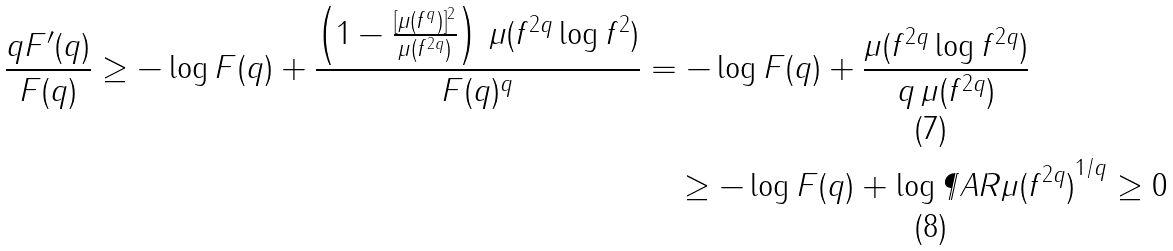<formula> <loc_0><loc_0><loc_500><loc_500>\frac { q F ^ { \prime } ( q ) } { F ( q ) } \geq - \log F ( q ) + \frac { \left ( 1 - \frac { [ \mu ( f ^ { q } ) ] ^ { 2 } } { \mu ( f ^ { 2 q } ) } \right ) \, \mu ( f ^ { 2 q } \log f ^ { 2 } ) } { F ( q ) ^ { q } } & = - \log F ( q ) + \frac { \mu ( f ^ { 2 q } \log f ^ { 2 q } ) } { q \, \mu ( f ^ { 2 q } ) } \\ & \quad \geq - \log F ( q ) + \log \P A R { \mu ( f ^ { 2 q } ) } ^ { 1 / q } \geq 0</formula> 